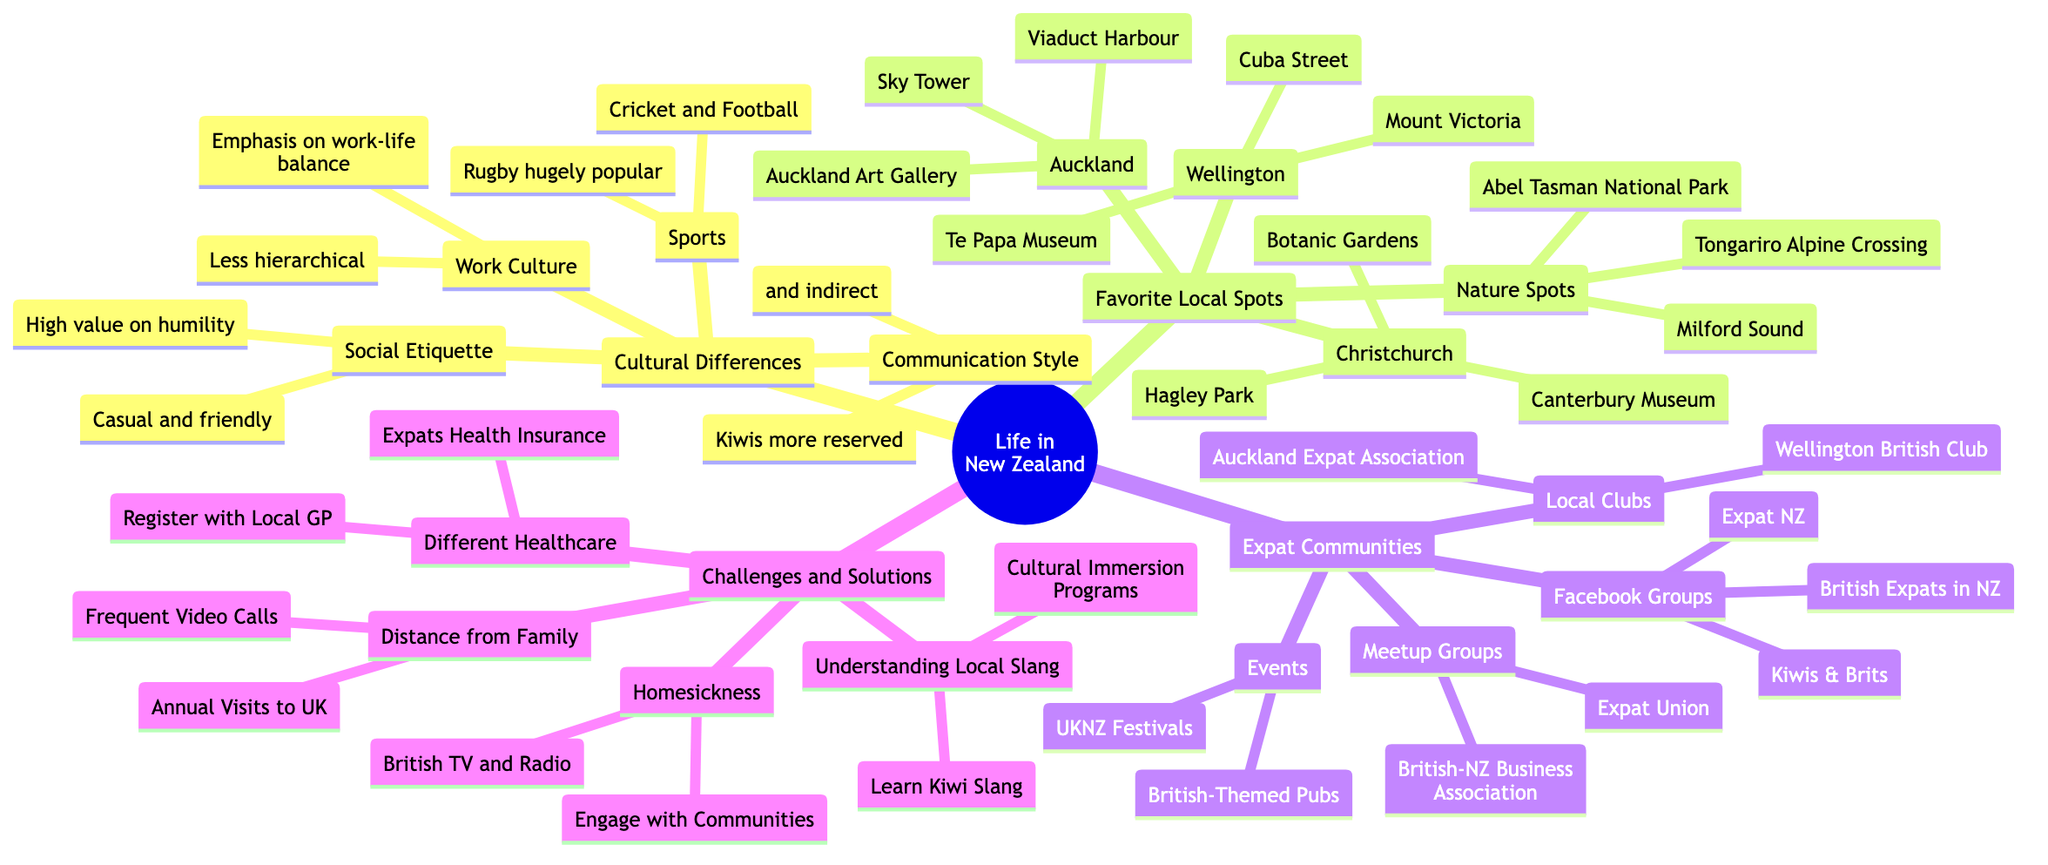What is a popular sport in New Zealand? The diagram specifically mentions that rugby is "hugely popular" in New Zealand, indicating its significance in Kiwi culture.
Answer: Rugby How many favorite local spots are listed for Christchurch? The diagram shows three main spots listed under Christchurch, which are the Botanic Gardens, Canterbury Museum, and Hagley Park. Therefore, counting these yields three.
Answer: 3 What are the names of two Facebook groups mentioned for expats? The diagram lists three Facebook groups under expat communities. The first two are "British Expats in New Zealand" and "Kiwis & Brits." Therefore, these two groups can be provided as the answer.
Answer: British Expats in New Zealand, Kiwis & Brits What solution is suggested for homesickness? Under the challenges and solutions section of the diagram, one of the solutions for homesickness is to "Engage with Local and Expat Communities." This solution is directly stated as a way to cope with this challenge.
Answer: Engage with Local and Expat Communities How does the work culture in New Zealand differ from that in Britain? The diagram highlights a significant distinction by stating that there is "more emphasis on work-life balance and less hierarchical" in New Zealand's work culture compared to the more traditional approach often seen in Britain.
Answer: More emphasis on work-life balance, less hierarchical What is a recommended activity for understanding local slang? The diagram outlines that a recommended approach to understand local slang is to "Learn Kiwi Slang," indicating a proactive step towards cultural adaptation.
Answer: Learn Kiwi Slang Which event is mentioned for expats in New Zealand? Among the events listed under expat communities, the "UKNZ Festivals" is mentioned, denoting a specific event that caters to the British expatriate experience in New Zealand.
Answer: UKNZ Festivals What is the communication style of Kiwis described as? The diagram characterizes the communication style of Kiwis as "generally more reserved and indirect" when compared to the British style, providing insight into cultural differences.
Answer: More reserved and indirect How many total categories are there under "Life in New Zealand"? The diagram indicates four main categories (Cultural Differences, Favorite Local Spots, Expat Communities, and Challenges and Solutions) under the section "Life in New Zealand," leading to a total count of four.
Answer: 4 